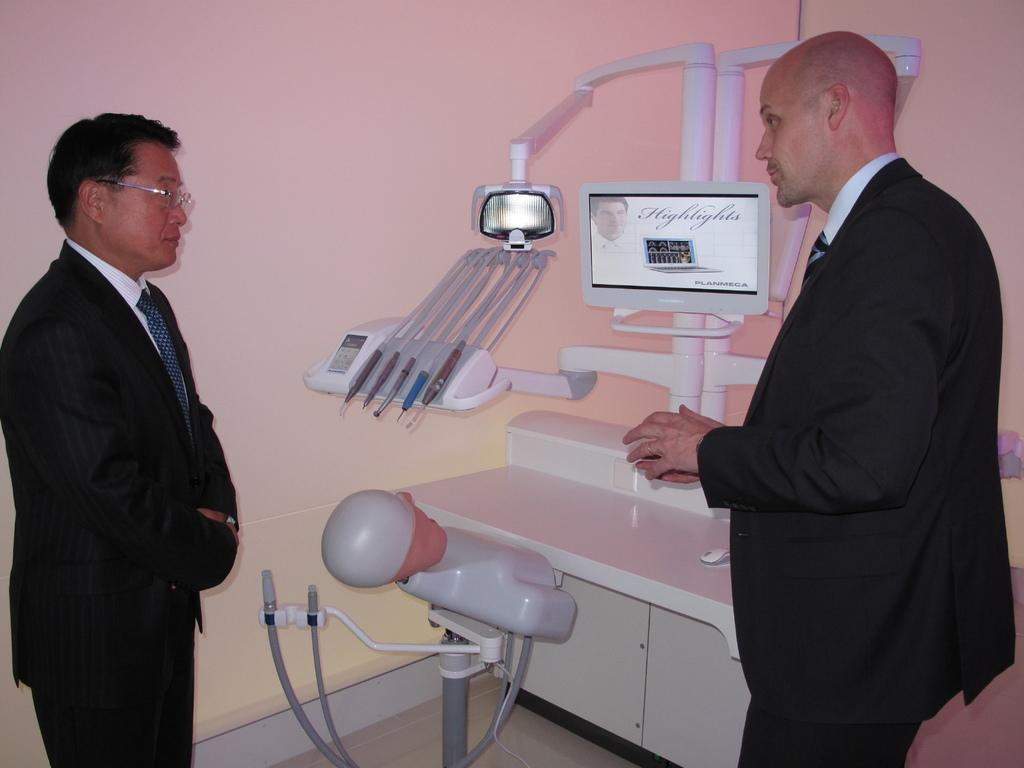How many people are present in the image? There are two people standing in the image. What color are the clothes worn by the people in the image? The people are wearing black color dress. What can be seen besides the people in the image? There is a machine, a screen, and a wall in the image. What is the color of the machine in the image? The machine is in white color. Can you see any leaves on the people's clothing in the image? There are no leaves visible on the people's clothing in the image. Are the people in the image making any requests or demands? There is no indication in the image of the people making any requests or demands. 